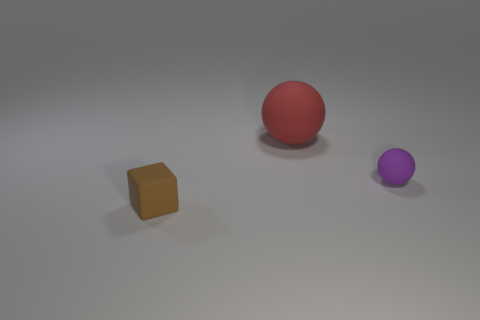Add 2 red rubber things. How many objects exist? 5 Subtract all blocks. How many objects are left? 2 Subtract all big red objects. Subtract all tiny brown rubber things. How many objects are left? 1 Add 3 brown matte objects. How many brown matte objects are left? 4 Add 3 small cyan matte blocks. How many small cyan matte blocks exist? 3 Subtract 0 blue cubes. How many objects are left? 3 